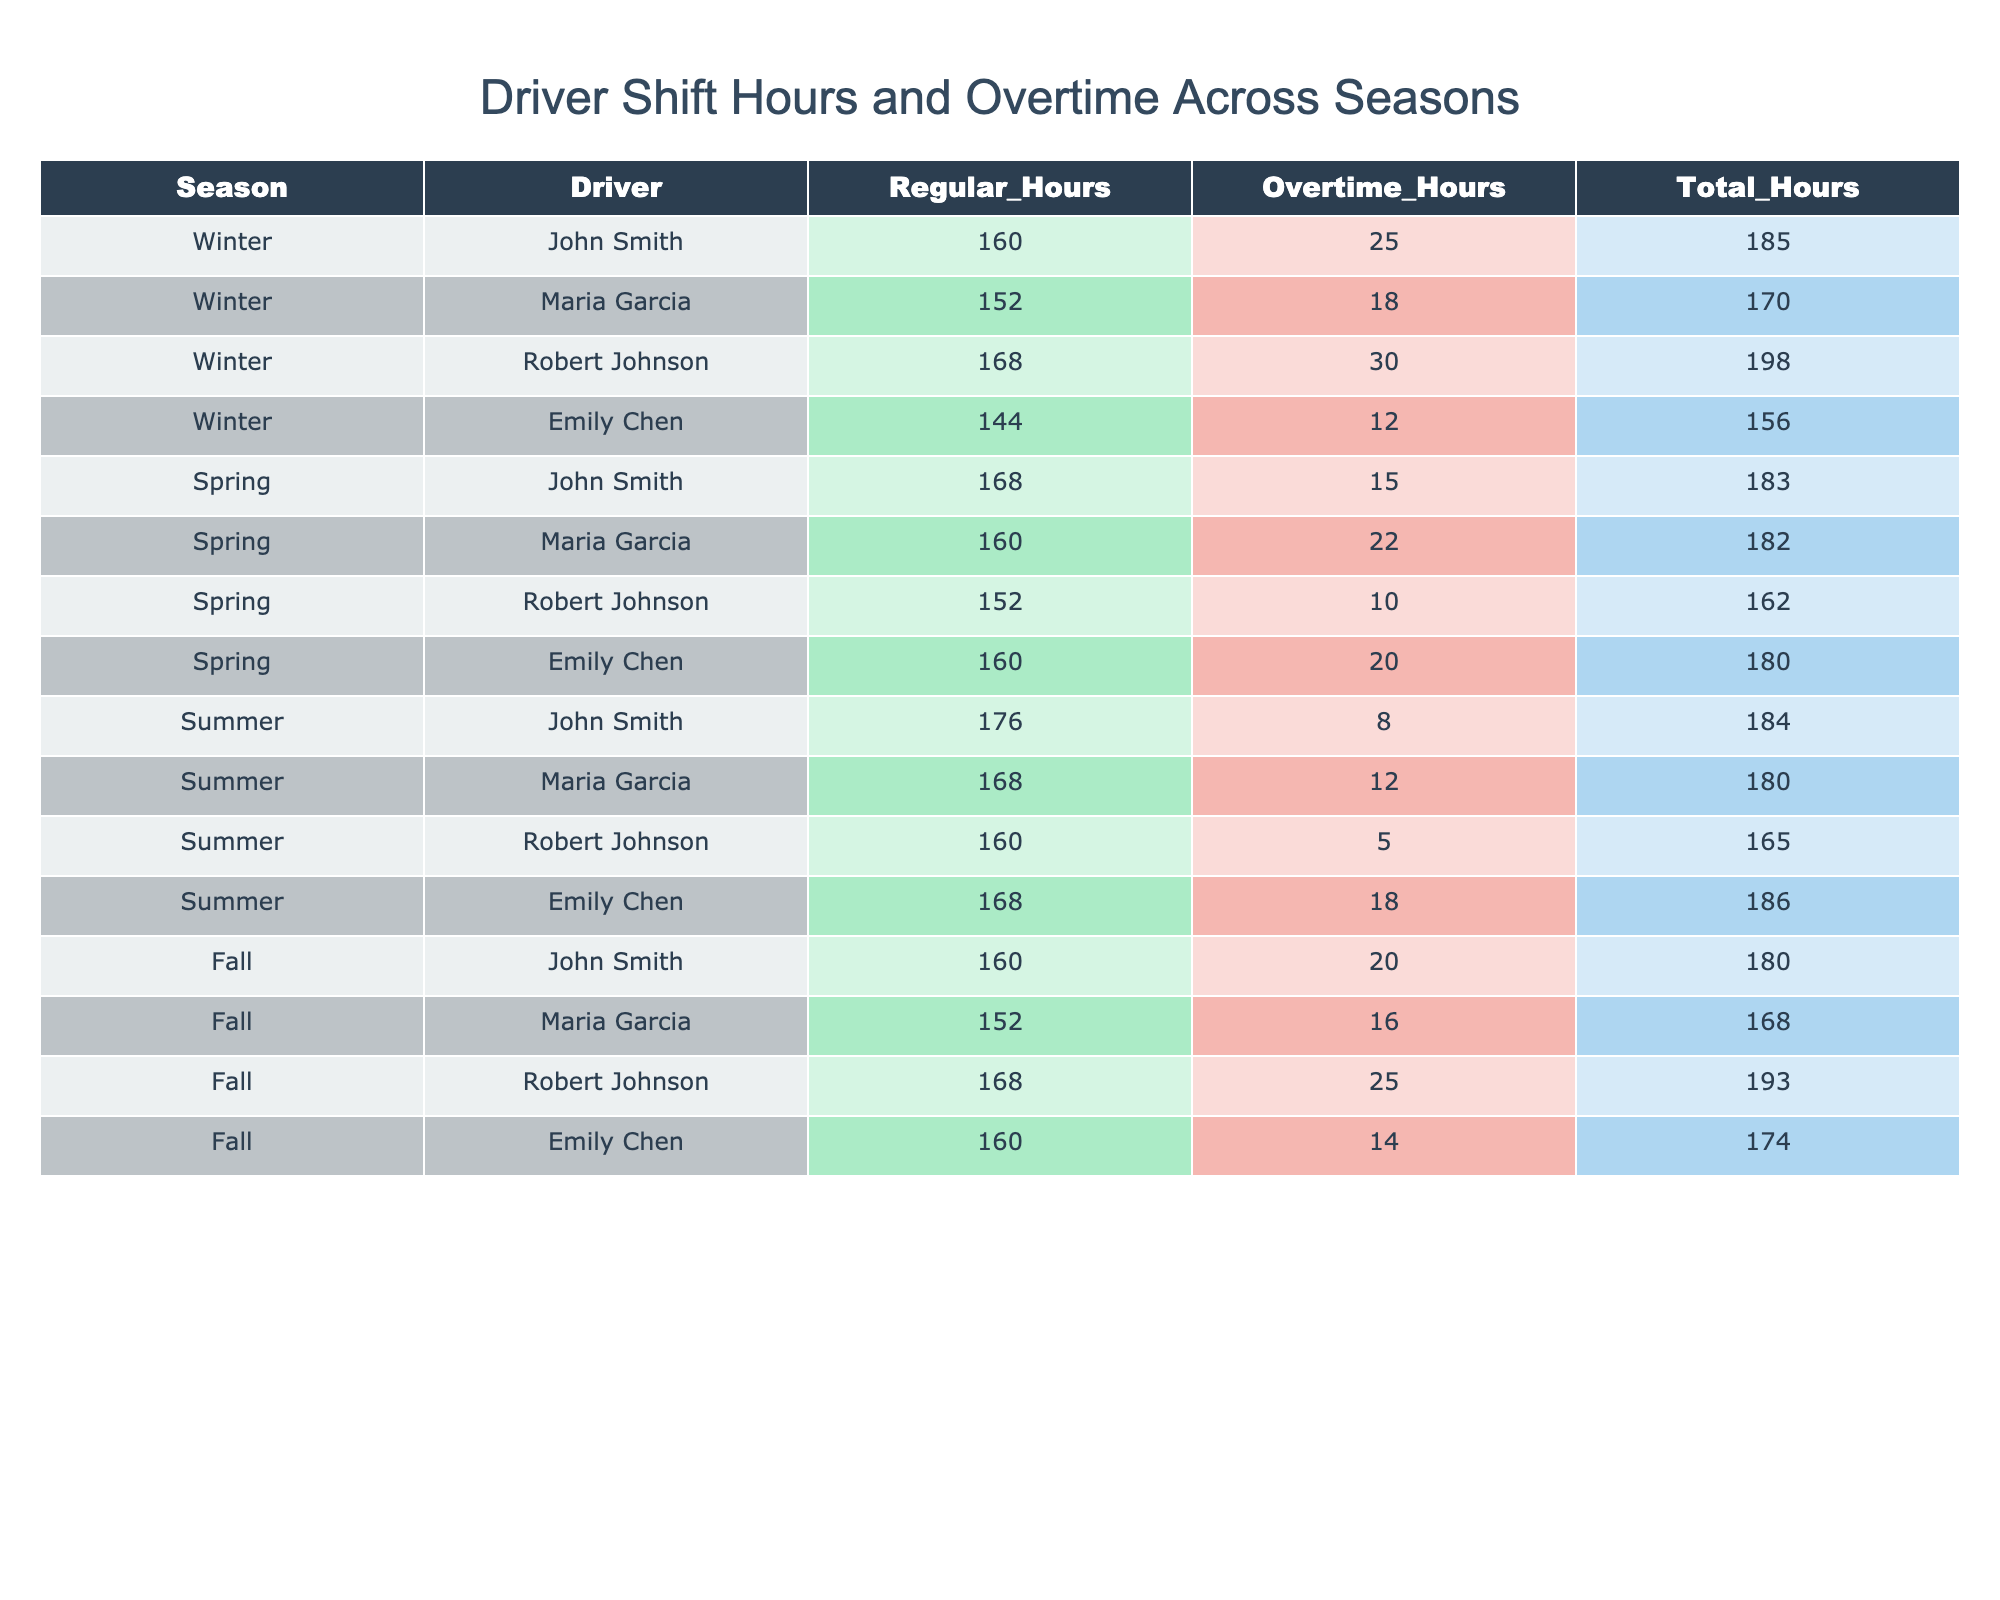What is the total overtime hours worked by John Smith in Winter? According to the table, John Smith worked 25 overtime hours in Winter.
Answer: 25 What is the total number of regular hours worked by all drivers in Spring? Adding up the regular hours for all drivers in Spring: 168 (John Smith) + 160 (Maria Garcia) + 152 (Robert Johnson) + 160 (Emily Chen) = 640 total regular hours.
Answer: 640 Did Emily Chen work more overtime hours in Summer than in Winter? In Summer, Emily Chen worked 18 overtime hours, while in Winter she worked 12 overtime hours. Since 18 > 12, the answer is yes.
Answer: Yes Which driver had the highest total hours in Fall? Looking at the Fall totals, Robert Johnson had 193 total hours, which is higher than the totals for other drivers in Fall.
Answer: Robert Johnson What is the average overtime hours worked by Maria Garcia across all seasons? Maria Garcia's overtime hours are: 18 (Winter) + 22 (Spring) + 12 (Summer) + 16 (Fall) = 68. There are 4 seasons, so the average is 68/4 = 17.
Answer: 17 In which season did Robert Johnson work the least overtime hours? In Winter, he worked 30 hours, Spring 10 hours, Summer 5 hours, and Fall 25 hours. The least is 5 hours in Summer.
Answer: Summer What is the total combined shift hours for all drivers in Winter? Adding the total hours for all drivers in Winter: 185 (John Smith) + 170 (Maria Garcia) + 198 (Robert Johnson) + 156 (Emily Chen) = 709 total hours.
Answer: 709 How much more overtime did John Smith work in Fall compared to Summer? John Smith worked 20 overtime hours in Fall and 8 in Summer; therefore, he worked 20 - 8 = 12 more hours in Fall.
Answer: 12 Did any driver work more than 180 total hours in Spring? The total hours worked by drivers in Spring are 183 (John Smith), 182 (Maria Garcia), 162 (Robert Johnson), and 180 (Emily Chen). Yes, John Smith and Maria Garcia both worked more than 180 hours.
Answer: Yes What is the median of total hours worked by all drivers during Winter? The total hours in Winter are 185, 170, 198, and 156, which when sorted are 156, 170, 185, and 198. The median is the average of the two middle values: (170 + 185) / 2 = 177.5.
Answer: 177.5 